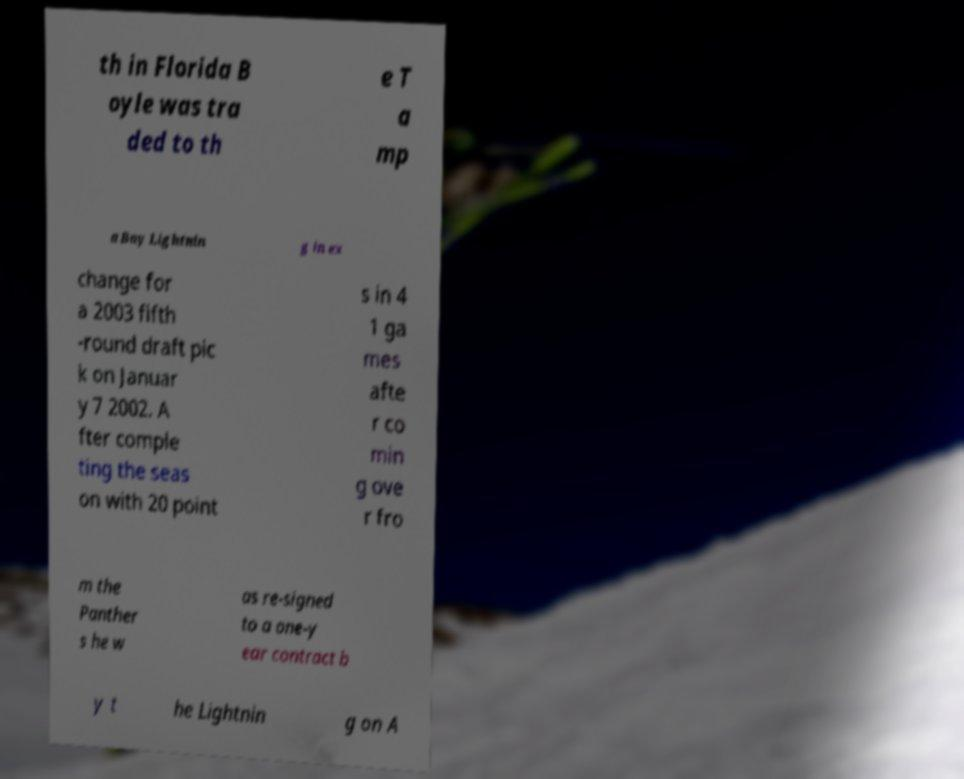What messages or text are displayed in this image? I need them in a readable, typed format. th in Florida B oyle was tra ded to th e T a mp a Bay Lightnin g in ex change for a 2003 fifth -round draft pic k on Januar y 7 2002. A fter comple ting the seas on with 20 point s in 4 1 ga mes afte r co min g ove r fro m the Panther s he w as re-signed to a one-y ear contract b y t he Lightnin g on A 